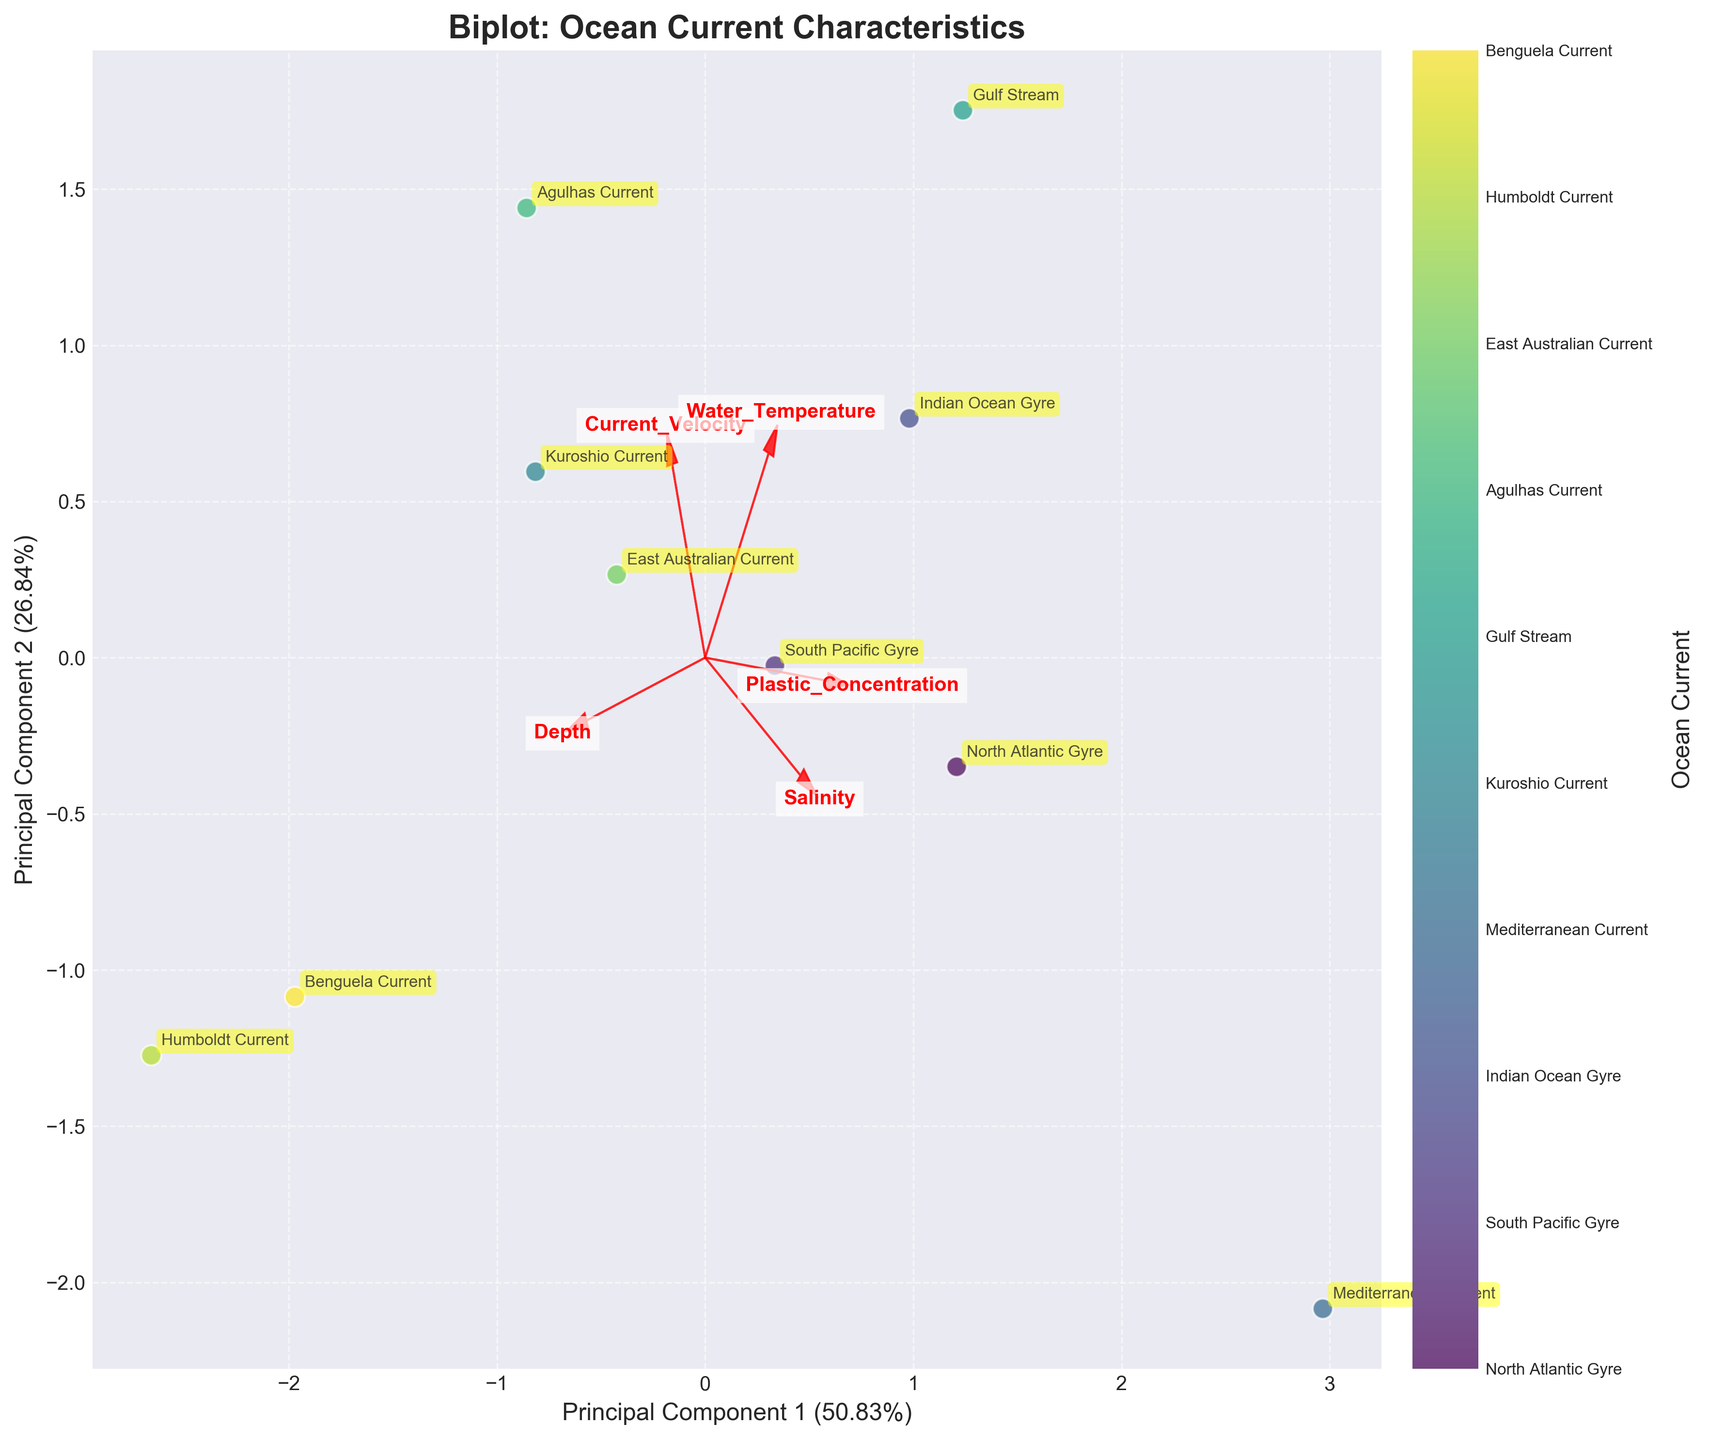What is the title of the plot? The title of a plot is usually located at the top and is created to give a clear indication of what the plot displays. In this case, the title is 'Biplot: Ocean Current Characteristics'.
Answer: Biplot: Ocean Current Characteristics How many ocean currents are represented in the biplot? To determine the number of ocean currents represented, count the distinct entries or data points on the plot. According to the colorbar and annotations, there are 10 ocean currents.
Answer: 10 Which variable has the largest influence on Principal Component 1? To identify the variable with the largest influence on Principal Component 1, look at the length of the arrows and their alignment with the x-axis. The variable with the longest arrow along the x-axis represents the largest influence.
Answer: Depth Compare the direction of the vector for 'Current Velocity' with that of 'Salinity'. By examining the directions of the arrows, 'Current Velocity' points more to the right and slightly upward, whereas 'Salinity' points prominently to the top left. The direction of 'Current Velocity' is almost perpendicular to that of 'Salinity'.
Answer: Perpendicular What percentage of the total variance is explained by Principal Component 2? The percentage of variance explained by a principal component is typically marked on the axis it corresponds to. Here it is noted on the y-axis. According to the y-axis, Principal Component 2 explains 28.03% of the variance.
Answer: 28.03% What patterns can be observed in relation to 'Plastic Concentration' and ocean currents? By looking at the direction and magnitude of the 'Plastic Concentration' vector and the placement of the ocean current data points, those with higher plastic concentration would be aligned with this vector. The Mediterranean Current and the North Atlantic Gyre are close to this vector suggesting higher plastic concentration in those currents.
Answer: Mediterranean Current and North Atlantic Gyre have higher plastic concentrations Which ocean current exhibits the highest value in 'Current Velocity'? 'Current Velocity' highest values can be interpreted by checking the proximity of the ocean currents to the 'Current Velocity' vector direction. The Gulf Stream is closest to this vector pointing to it having the highest value.
Answer: Gulf Stream How are 'Water Temperature' and 'Plastic Concentration' related in this biplot? Observing how vectors align or diverge helps understand relationships. 'Water Temperature' and 'Plastic Concentration' arrows both point in the same general direction, indicating a positive correlation.
Answer: Positively correlated Which two variables seem to be the most negatively correlated based on the biplot? Negative correlation is indicated by vectors pointing in opposite directions. Here, 'Salinity' and 'Current Velocity' vectors point almost in opposite directions, indicating high negative correlation.
Answer: Salinity and Current Velocity What can be inferred about the 'Benguela Current' in terms of 'Depth' and 'Plastic Concentration'? By locating the 'Benguela Current' on the biplot and observing its position relative to the 'Depth' and 'Plastic Concentration' vectors, it appears far from the 'Plastic Concentration' vector, suggesting low plastic concentration, and aligns more closely with 'Depth' implying it is deep.
Answer: Low plastic concentration, deep depth 